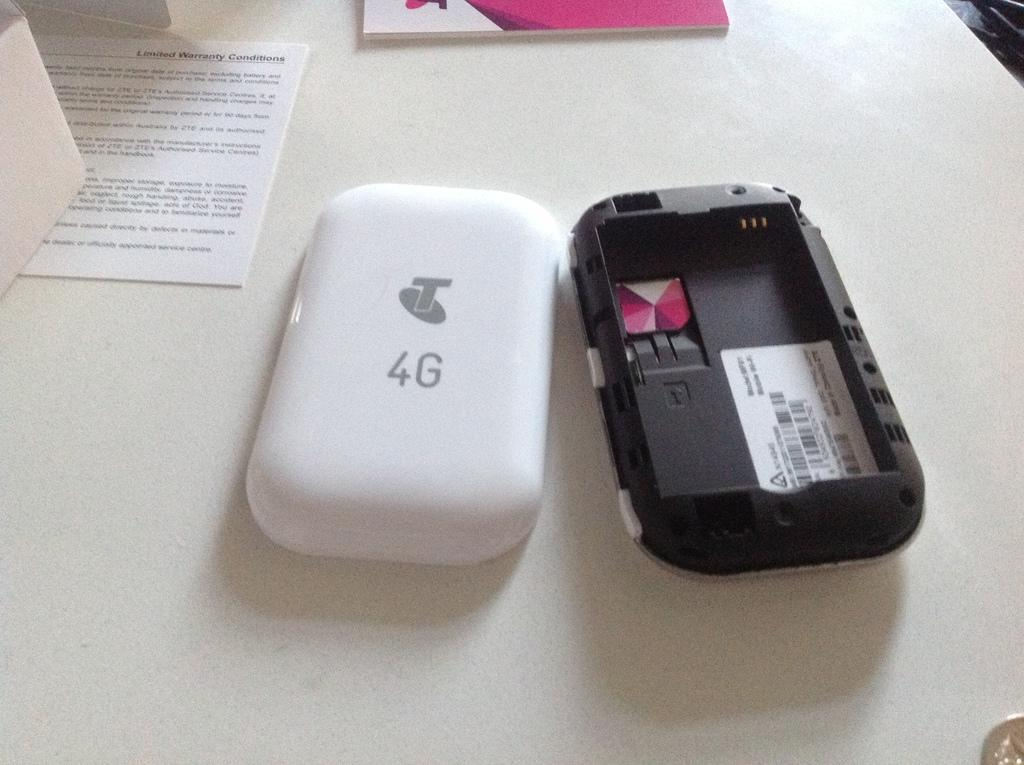Provide a one-sentence caption for the provided image. A 4G phone is opened and laying on a table. 